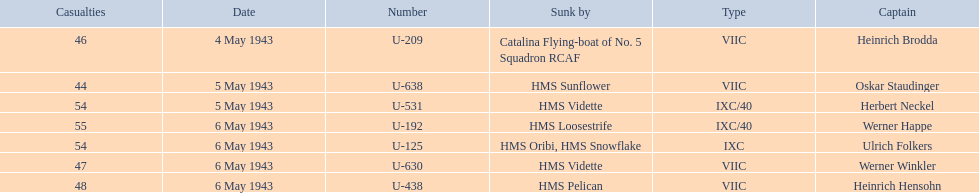What boats were lost on may 5? U-638, U-531. Who were the captains of those boats? Oskar Staudinger, Herbert Neckel. Which captain was not oskar staudinger? Herbert Neckel. 